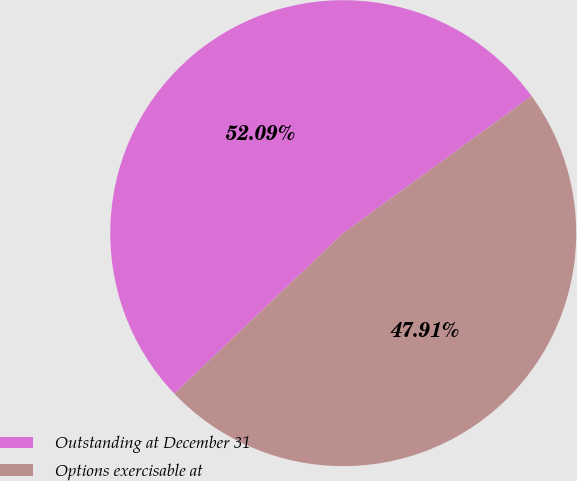Convert chart to OTSL. <chart><loc_0><loc_0><loc_500><loc_500><pie_chart><fcel>Outstanding at December 31<fcel>Options exercisable at<nl><fcel>52.09%<fcel>47.91%<nl></chart> 